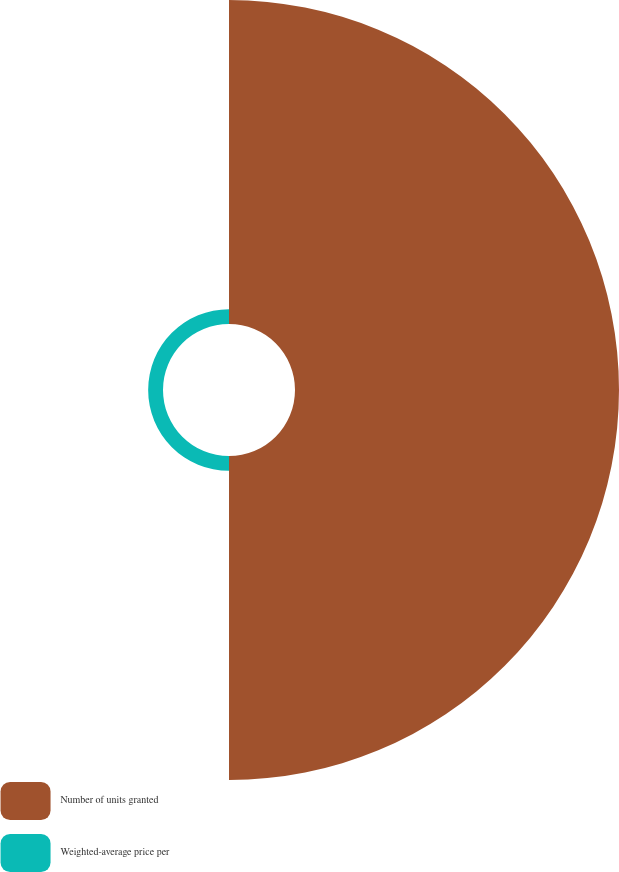Convert chart. <chart><loc_0><loc_0><loc_500><loc_500><pie_chart><fcel>Number of units granted<fcel>Weighted-average price per<nl><fcel>95.62%<fcel>4.38%<nl></chart> 